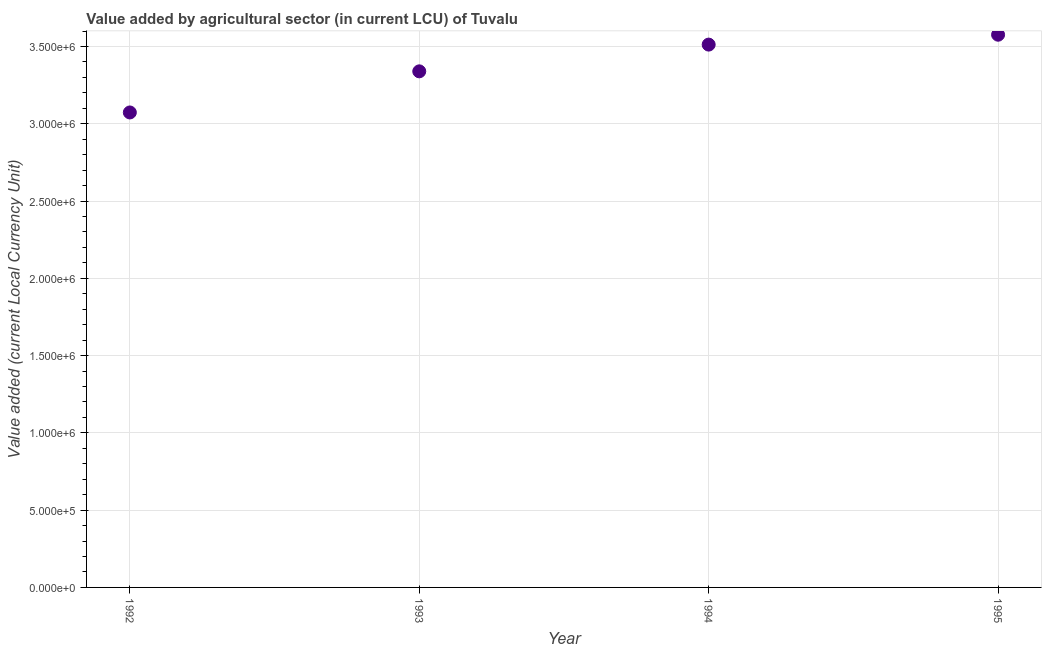What is the value added by agriculture sector in 1992?
Make the answer very short. 3.07e+06. Across all years, what is the maximum value added by agriculture sector?
Make the answer very short. 3.58e+06. Across all years, what is the minimum value added by agriculture sector?
Offer a very short reply. 3.07e+06. In which year was the value added by agriculture sector minimum?
Provide a short and direct response. 1992. What is the sum of the value added by agriculture sector?
Give a very brief answer. 1.35e+07. What is the difference between the value added by agriculture sector in 1993 and 1995?
Offer a very short reply. -2.37e+05. What is the average value added by agriculture sector per year?
Keep it short and to the point. 3.38e+06. What is the median value added by agriculture sector?
Make the answer very short. 3.43e+06. In how many years, is the value added by agriculture sector greater than 1000000 LCU?
Give a very brief answer. 4. What is the ratio of the value added by agriculture sector in 1994 to that in 1995?
Your answer should be compact. 0.98. Is the value added by agriculture sector in 1993 less than that in 1994?
Provide a short and direct response. Yes. What is the difference between the highest and the second highest value added by agriculture sector?
Provide a short and direct response. 6.40e+04. What is the difference between the highest and the lowest value added by agriculture sector?
Your answer should be compact. 5.03e+05. In how many years, is the value added by agriculture sector greater than the average value added by agriculture sector taken over all years?
Your answer should be very brief. 2. Does the value added by agriculture sector monotonically increase over the years?
Your answer should be very brief. Yes. How many dotlines are there?
Ensure brevity in your answer.  1. What is the difference between two consecutive major ticks on the Y-axis?
Ensure brevity in your answer.  5.00e+05. Are the values on the major ticks of Y-axis written in scientific E-notation?
Provide a succinct answer. Yes. What is the title of the graph?
Make the answer very short. Value added by agricultural sector (in current LCU) of Tuvalu. What is the label or title of the X-axis?
Your answer should be very brief. Year. What is the label or title of the Y-axis?
Your response must be concise. Value added (current Local Currency Unit). What is the Value added (current Local Currency Unit) in 1992?
Provide a succinct answer. 3.07e+06. What is the Value added (current Local Currency Unit) in 1993?
Your answer should be compact. 3.34e+06. What is the Value added (current Local Currency Unit) in 1994?
Offer a very short reply. 3.51e+06. What is the Value added (current Local Currency Unit) in 1995?
Give a very brief answer. 3.58e+06. What is the difference between the Value added (current Local Currency Unit) in 1992 and 1993?
Give a very brief answer. -2.66e+05. What is the difference between the Value added (current Local Currency Unit) in 1992 and 1994?
Give a very brief answer. -4.39e+05. What is the difference between the Value added (current Local Currency Unit) in 1992 and 1995?
Make the answer very short. -5.03e+05. What is the difference between the Value added (current Local Currency Unit) in 1993 and 1994?
Your answer should be very brief. -1.73e+05. What is the difference between the Value added (current Local Currency Unit) in 1993 and 1995?
Make the answer very short. -2.37e+05. What is the difference between the Value added (current Local Currency Unit) in 1994 and 1995?
Offer a terse response. -6.40e+04. What is the ratio of the Value added (current Local Currency Unit) in 1992 to that in 1993?
Provide a short and direct response. 0.92. What is the ratio of the Value added (current Local Currency Unit) in 1992 to that in 1994?
Offer a very short reply. 0.88. What is the ratio of the Value added (current Local Currency Unit) in 1992 to that in 1995?
Keep it short and to the point. 0.86. What is the ratio of the Value added (current Local Currency Unit) in 1993 to that in 1994?
Ensure brevity in your answer.  0.95. What is the ratio of the Value added (current Local Currency Unit) in 1993 to that in 1995?
Ensure brevity in your answer.  0.93. What is the ratio of the Value added (current Local Currency Unit) in 1994 to that in 1995?
Ensure brevity in your answer.  0.98. 